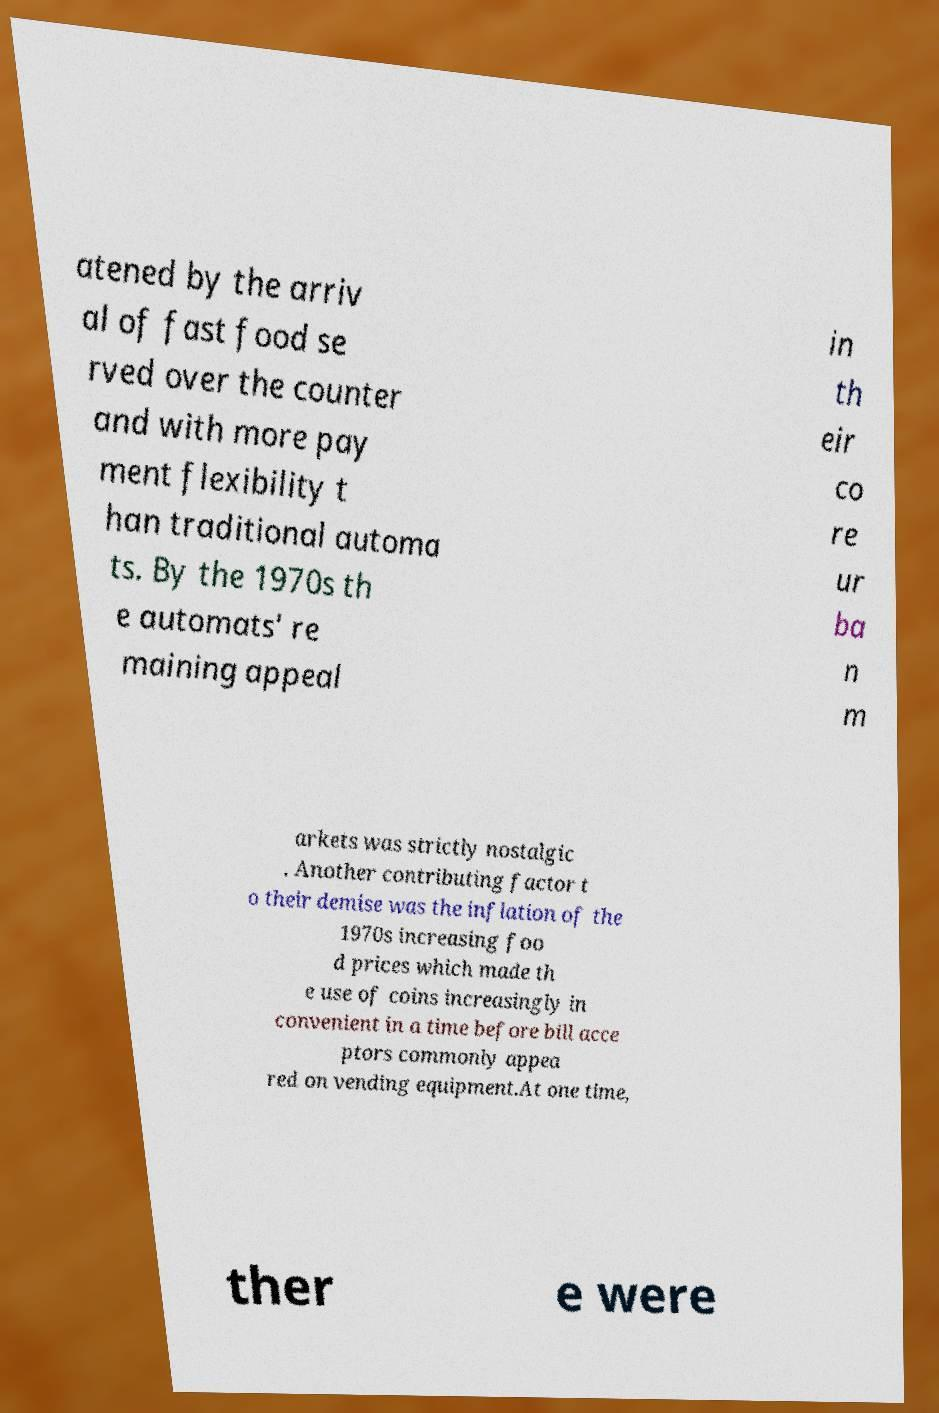Could you extract and type out the text from this image? atened by the arriv al of fast food se rved over the counter and with more pay ment flexibility t han traditional automa ts. By the 1970s th e automats' re maining appeal in th eir co re ur ba n m arkets was strictly nostalgic . Another contributing factor t o their demise was the inflation of the 1970s increasing foo d prices which made th e use of coins increasingly in convenient in a time before bill acce ptors commonly appea red on vending equipment.At one time, ther e were 